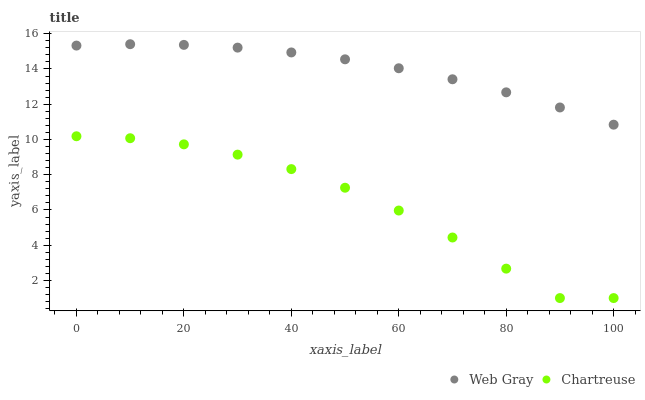Does Chartreuse have the minimum area under the curve?
Answer yes or no. Yes. Does Web Gray have the maximum area under the curve?
Answer yes or no. Yes. Does Web Gray have the minimum area under the curve?
Answer yes or no. No. Is Web Gray the smoothest?
Answer yes or no. Yes. Is Chartreuse the roughest?
Answer yes or no. Yes. Is Web Gray the roughest?
Answer yes or no. No. Does Chartreuse have the lowest value?
Answer yes or no. Yes. Does Web Gray have the lowest value?
Answer yes or no. No. Does Web Gray have the highest value?
Answer yes or no. Yes. Is Chartreuse less than Web Gray?
Answer yes or no. Yes. Is Web Gray greater than Chartreuse?
Answer yes or no. Yes. Does Chartreuse intersect Web Gray?
Answer yes or no. No. 